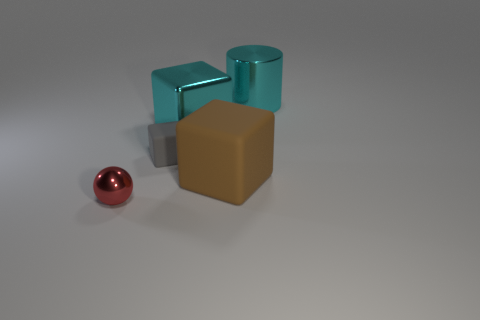There is a brown object that is made of the same material as the tiny gray cube; what shape is it?
Offer a very short reply. Cube. Are there any other things of the same color as the tiny matte thing?
Give a very brief answer. No. What is the material of the cyan object that is the same shape as the brown rubber thing?
Give a very brief answer. Metal. What number of other objects are the same size as the metallic sphere?
Your answer should be compact. 1. What material is the brown object?
Offer a very short reply. Rubber. Are there more rubber cubes that are left of the shiny ball than large cyan matte things?
Ensure brevity in your answer.  No. Are any tiny gray matte cubes visible?
Your response must be concise. Yes. What number of other objects are the same shape as the red thing?
Offer a terse response. 0. Does the large metal thing to the left of the large cyan metal cylinder have the same color as the tiny object that is on the right side of the red thing?
Offer a terse response. No. There is a thing that is behind the large cube that is behind the small object that is behind the brown matte object; what size is it?
Offer a very short reply. Large. 